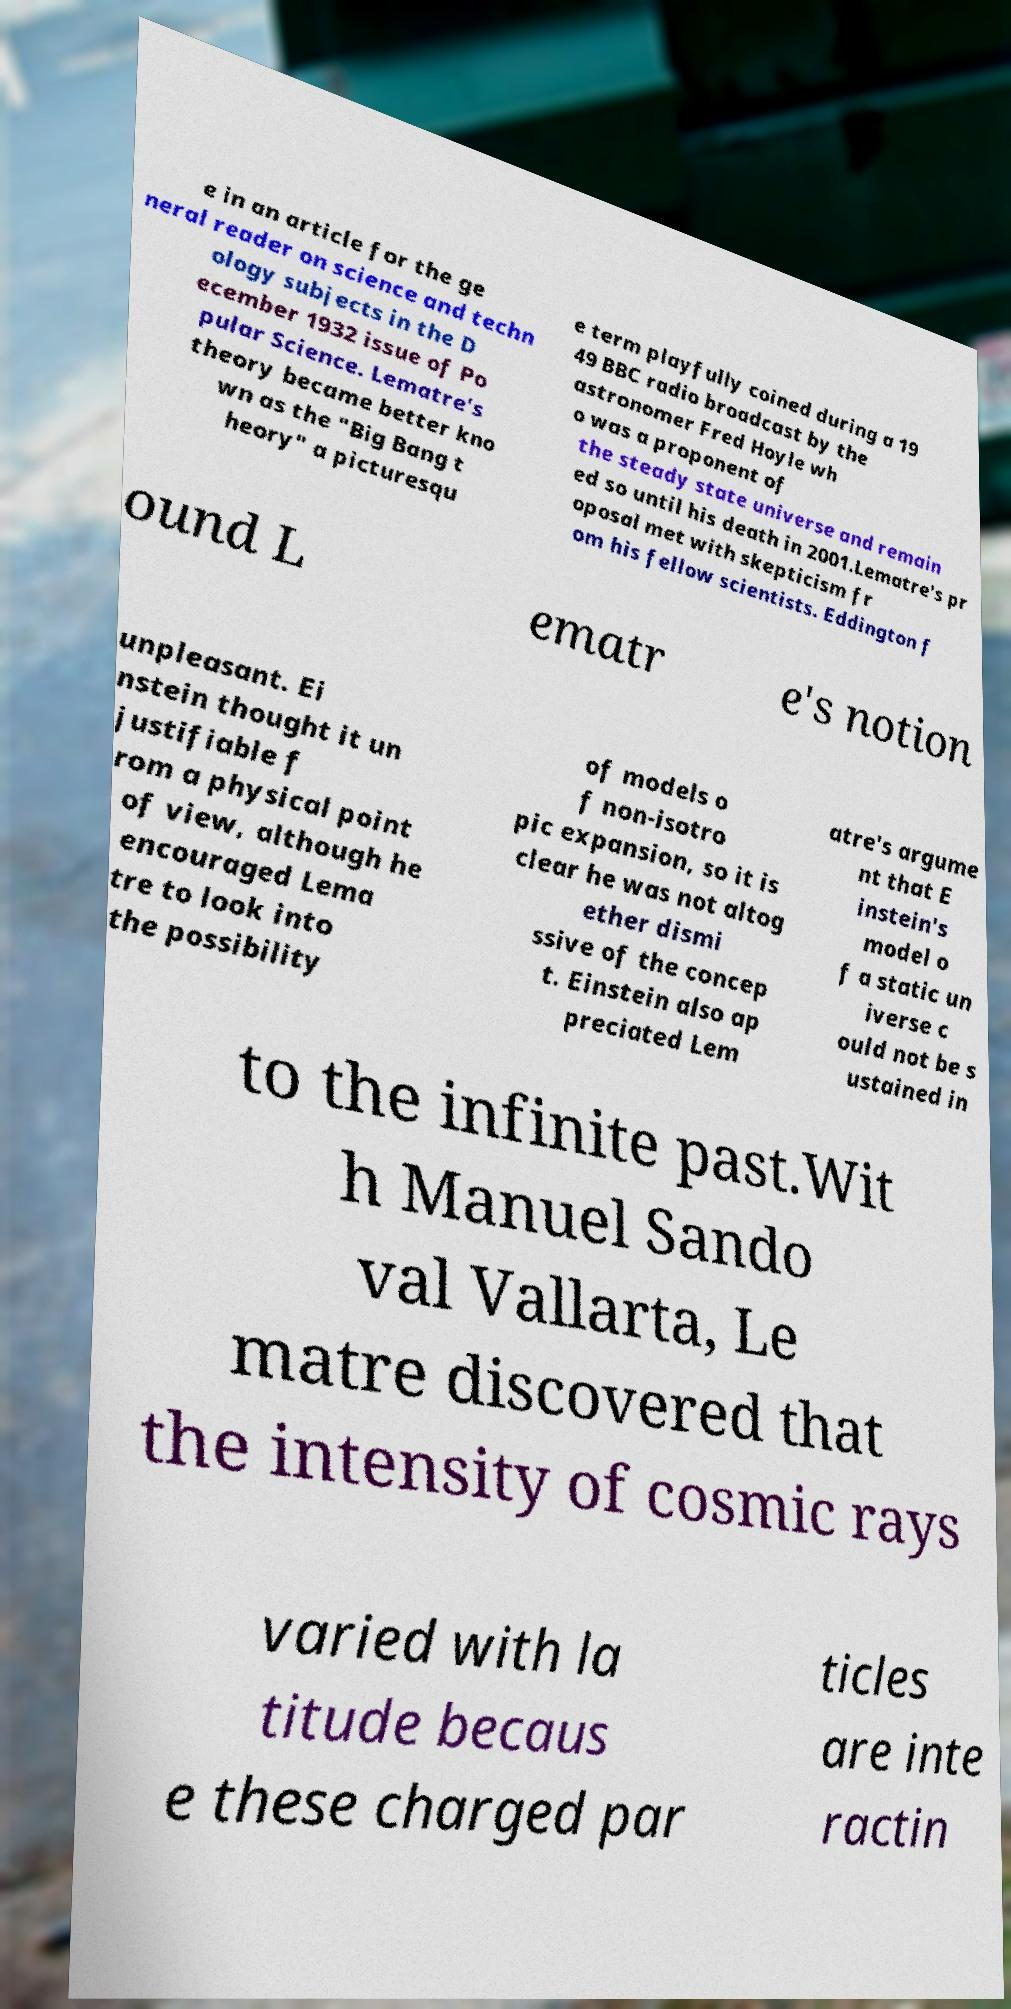Could you extract and type out the text from this image? e in an article for the ge neral reader on science and techn ology subjects in the D ecember 1932 issue of Po pular Science. Lematre's theory became better kno wn as the "Big Bang t heory" a picturesqu e term playfully coined during a 19 49 BBC radio broadcast by the astronomer Fred Hoyle wh o was a proponent of the steady state universe and remain ed so until his death in 2001.Lematre's pr oposal met with skepticism fr om his fellow scientists. Eddington f ound L ematr e's notion unpleasant. Ei nstein thought it un justifiable f rom a physical point of view, although he encouraged Lema tre to look into the possibility of models o f non-isotro pic expansion, so it is clear he was not altog ether dismi ssive of the concep t. Einstein also ap preciated Lem atre's argume nt that E instein's model o f a static un iverse c ould not be s ustained in to the infinite past.Wit h Manuel Sando val Vallarta, Le matre discovered that the intensity of cosmic rays varied with la titude becaus e these charged par ticles are inte ractin 